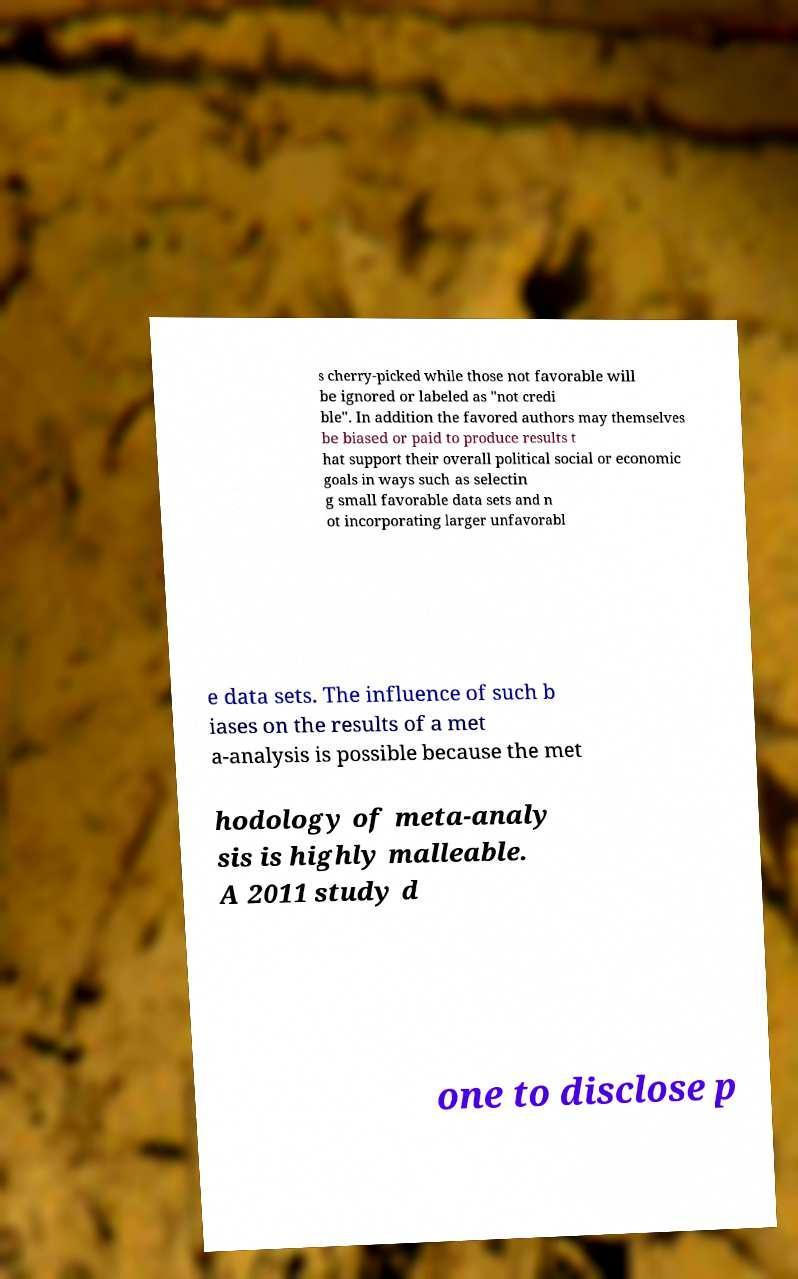Can you read and provide the text displayed in the image?This photo seems to have some interesting text. Can you extract and type it out for me? s cherry-picked while those not favorable will be ignored or labeled as "not credi ble". In addition the favored authors may themselves be biased or paid to produce results t hat support their overall political social or economic goals in ways such as selectin g small favorable data sets and n ot incorporating larger unfavorabl e data sets. The influence of such b iases on the results of a met a-analysis is possible because the met hodology of meta-analy sis is highly malleable. A 2011 study d one to disclose p 